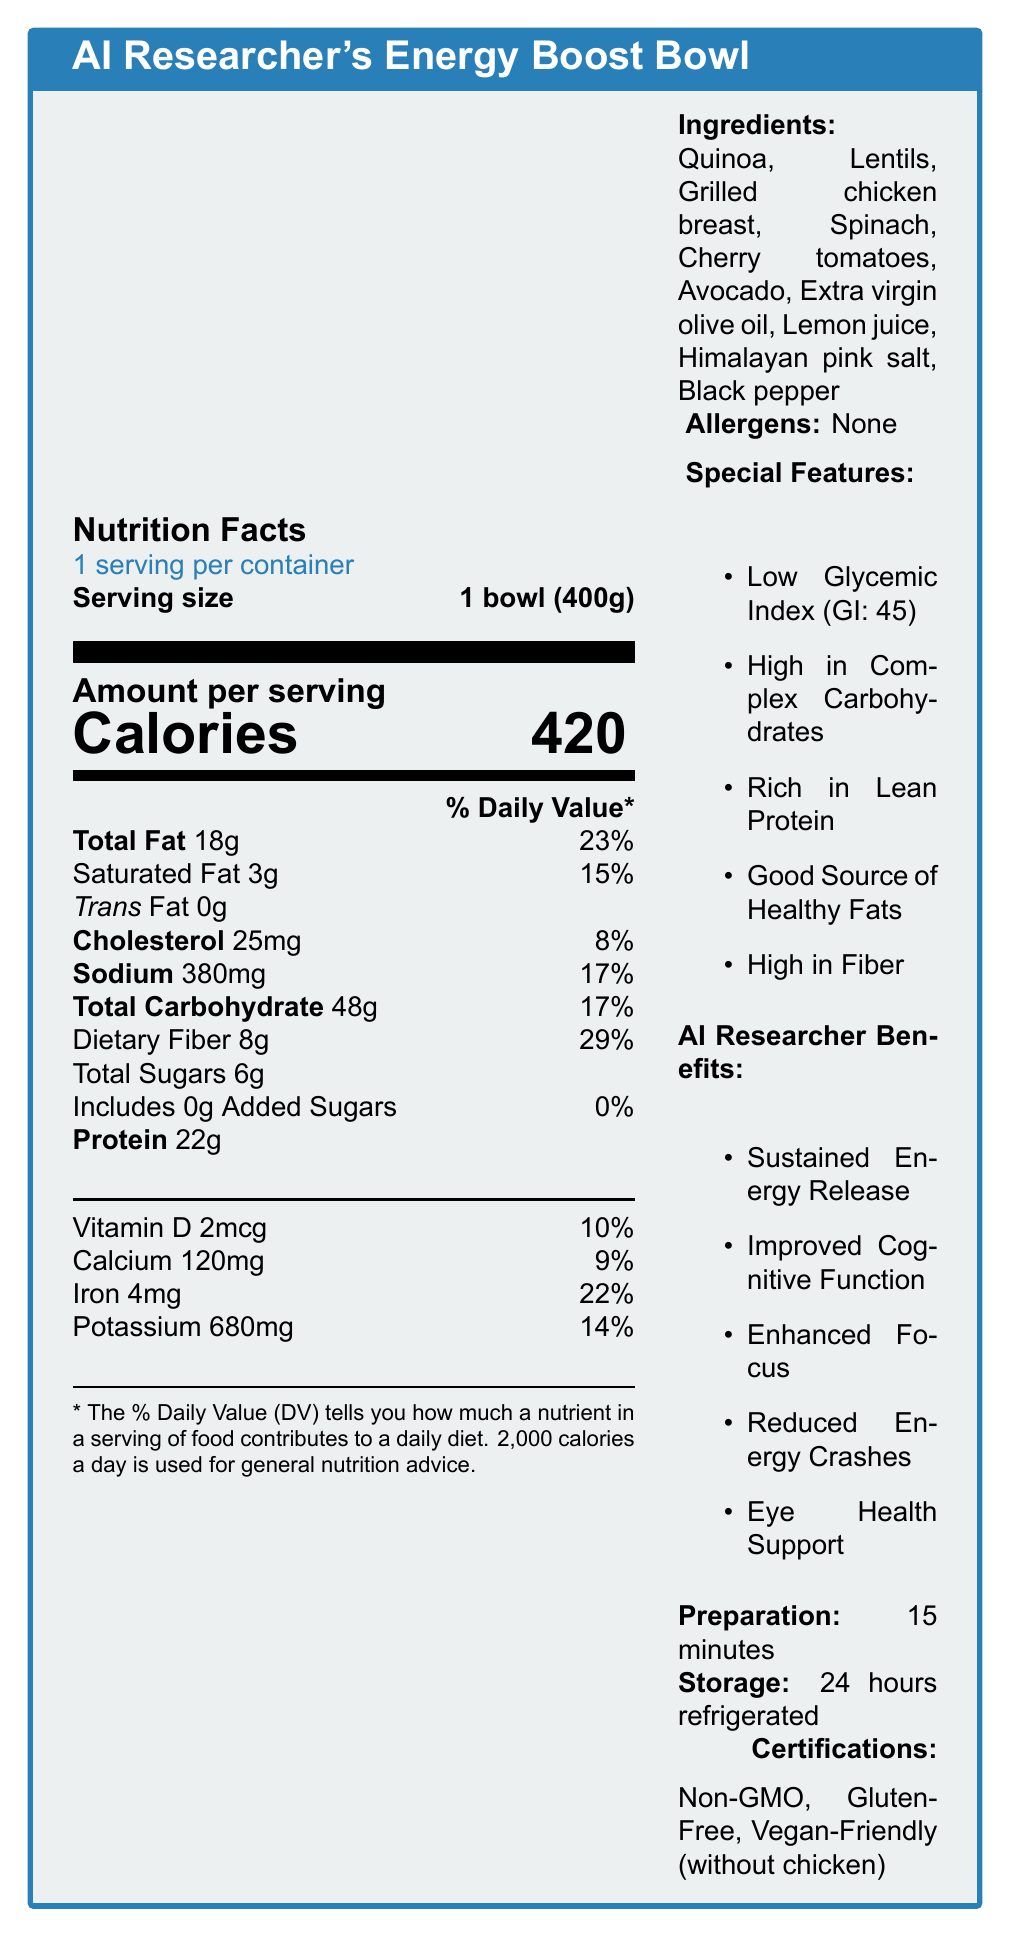what is the serving size for the meal? The document clearly states that the serving size is 1 bowl (400g).
Answer: 1 bowl (400g) how many calories are in one serving? The Nutrition Facts section lists the calories as 420 for one serving.
Answer: 420 how much total fat does the meal contain? The Nutrition Facts section mentions that the total fat is 18g.
Answer: 18g what percentage of the daily value does the dietary fiber cover? The document indicates that the dietary fiber contributes 29% to the daily value.
Answer: 29% does the meal contain any trans fat? The Nutrition Facts state that it contains 0g of trans fat.
Answer: No what are the main ingredients in the meal? The list of ingredients is provided in the Ingredients section.
Answer: Quinoa, Lentils, Grilled chicken breast, Spinach, Cherry tomatoes, Avocado, Extra virgin olive oil, Lemon juice, Himalayan pink salt, Black pepper what special features does the meal have? The document lists these under Special Features.
Answer: Low Glycemic Index, High in Complex Carbohydrates, Rich in Lean Protein, Good Source of Healthy Fats, High in Fiber what are the benefits of the meal for AI researchers? The AI Researcher Benefits section details these benefits.
Answer: Sustained Energy Release, Improved Cognitive Function, Enhanced Focus, Reduced Energy Crashes, Eye Health Support how much protein does the meal contain? The Nutrition Facts section lists 22g of protein.
Answer: 22g how much sodium is in the meal? The Nutrition Facts section mentions that the sodium content is 380mg.
Answer: 380mg the meal’s glycemic index and glycemic load are: A. GI: 50, GL: 20 B. GI: 45, GL: 14 C. GI: 40, GL: 10 D. GI: 55, GL: 18 The Special Features identify the Glycemic Index as 45 and Glycemic Load as 14.
Answer: B which of the following nutrients are included in the Nutrition Facts? (select all that apply) I. Vitamin D II. Potassium III. Vitamin B12 IV. Sodium The Nutrition Facts section includes Vitamin D, Potassium, and Sodium, but not Vitamin B12.
Answer: I, II, IV does the meal contain any allergens? The document states that there are no allergens.
Answer: No summarize the main features and benefits of the "AI Researcher's Energy Boost Bowl". The document provides a detailed Nutrition Facts section, lists ingredients and special features, emphasizing the meal’s benefits for AI researchers, and includes preparation and storage instructions as well as sustainability information.
Answer: The "AI Researcher's Energy Boost Bowl" is a nutritious, low-glycemic index meal designed to maintain stable energy levels during extended machine learning model training. It has 420 calories per serving, with a good balance of fats, carbohydrates, fiber, and protein. It is high in dietary fiber, low in added sugars, and includes ingredients like quinoa, lentils, and chicken breast. The dish is packed with vitamins and minerals and provides benefits like sustained energy release, improved cognitive function, enhanced focus, and eye health support. what is the recipe for preparing the meal? The document mentions preparation takes 15 minutes but does not provide the actual recipe or steps to prepare the meal.
Answer: Not enough information what is the preparation time for the meal? The preparation time is stated as 15 minutes in the document.
Answer: 15 minutes how should the meal be stored for maximum freshness? The Storage Instructions section advises storing the meal in an airtight container in the refrigerator.
Answer: Store in an airtight container in the refrigerator what certifications does the meal have? The document lists these certifications under the Certifications section.
Answer: Non-GMO, Gluten-Free, Vegan-Friendly (without chicken) 